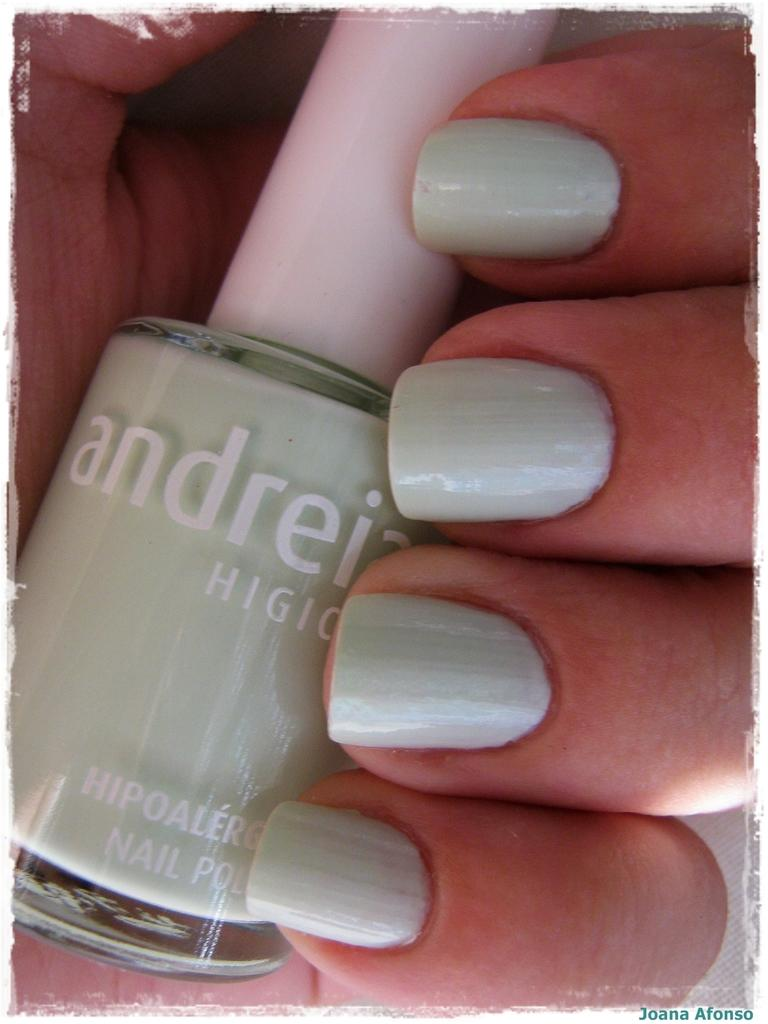<image>
Share a concise interpretation of the image provided. A close up of a bottle of andreia brand nail polish in a hand 